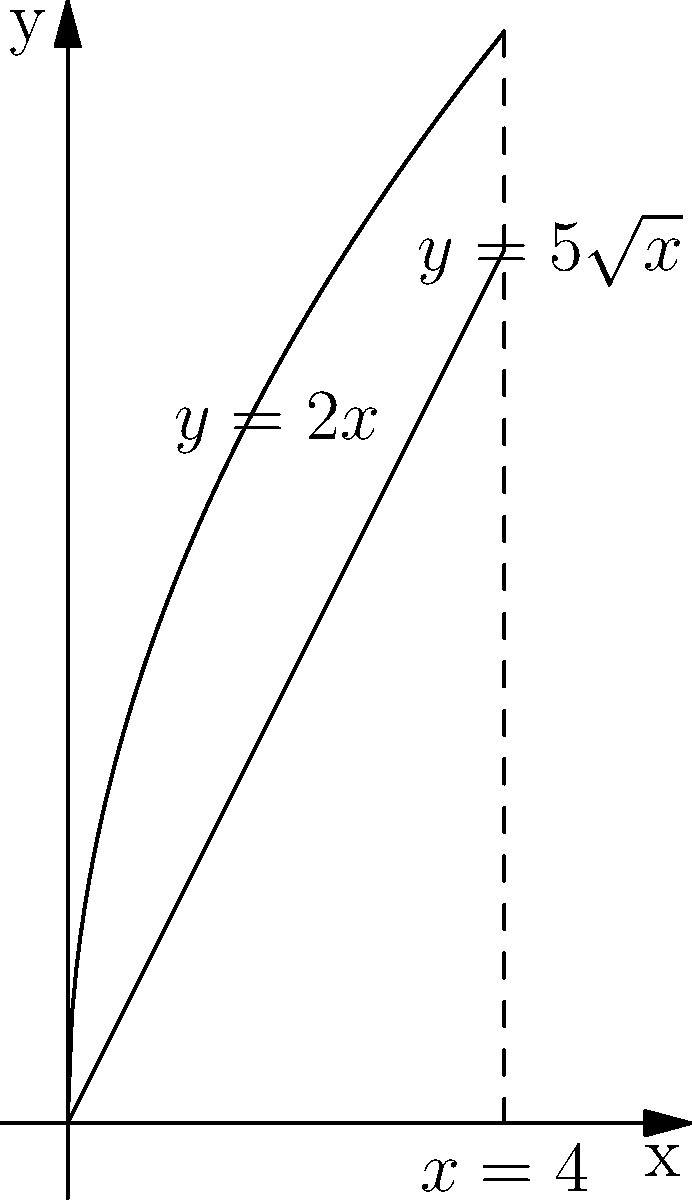A digital library's data storage needs are modeled by rotating the region bounded by $y=5\sqrt{x}$, $y=2x$, and $x=4$ around the x-axis. If each unit of volume represents 1 terabyte of data, how many terabytes of storage are needed for this digital library? Round your answer to the nearest whole number. To solve this problem, we need to use the washer method for solids of revolution:

1) The volume is given by the formula:
   $$V = \pi \int_0^4 [(5\sqrt{x})^2 - (2x)^2] dx$$

2) Expand the integrand:
   $$V = \pi \int_0^4 (25x - 4x^2) dx$$

3) Integrate:
   $$V = \pi [\frac{25x^2}{2} - \frac{4x^3}{3}]_0^4$$

4) Evaluate the integral:
   $$V = \pi [(200 - \frac{256}{3}) - 0]$$
   $$V = \pi (200 - \frac{256}{3})$$
   $$V = \pi (\frac{600 - 256}{3})$$
   $$V = \pi (\frac{344}{3})$$

5) Calculate the final value:
   $$V \approx 360.6$$

6) Round to the nearest whole number:
   $$V \approx 361$$

Therefore, the digital library needs approximately 361 terabytes of storage.
Answer: 361 terabytes 